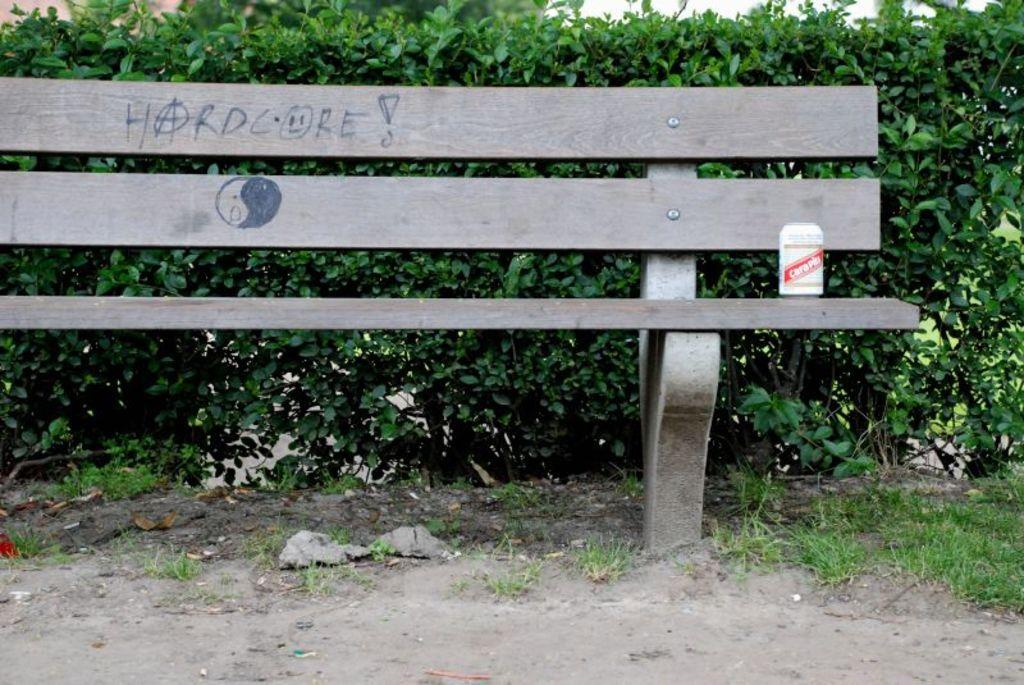What type of seating is visible in the image? There is a bench in the image. What object is placed on the bench? A tin is placed on the bench. What can be seen in the background of the image? There is a hedge in the background of the image. What type of vegetation is at the bottom of the image? Grass is present at the bottom of the image. What type of operation is being performed on the linen in the image? There is no linen or operation present in the image. 